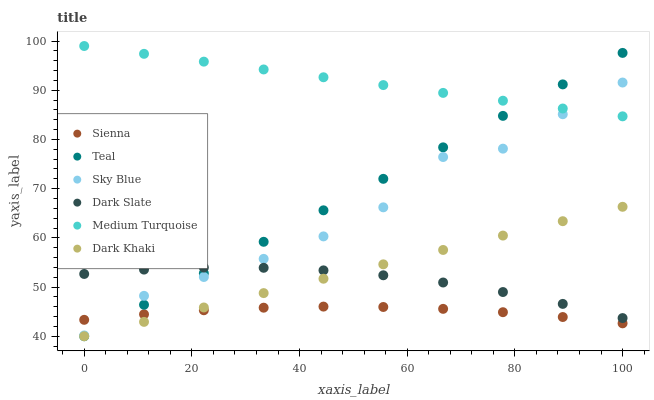Does Sienna have the minimum area under the curve?
Answer yes or no. Yes. Does Medium Turquoise have the maximum area under the curve?
Answer yes or no. Yes. Does Teal have the minimum area under the curve?
Answer yes or no. No. Does Teal have the maximum area under the curve?
Answer yes or no. No. Is Dark Khaki the smoothest?
Answer yes or no. Yes. Is Sky Blue the roughest?
Answer yes or no. Yes. Is Sienna the smoothest?
Answer yes or no. No. Is Sienna the roughest?
Answer yes or no. No. Does Dark Khaki have the lowest value?
Answer yes or no. Yes. Does Sienna have the lowest value?
Answer yes or no. No. Does Medium Turquoise have the highest value?
Answer yes or no. Yes. Does Teal have the highest value?
Answer yes or no. No. Is Dark Khaki less than Sky Blue?
Answer yes or no. Yes. Is Medium Turquoise greater than Dark Slate?
Answer yes or no. Yes. Does Sky Blue intersect Teal?
Answer yes or no. Yes. Is Sky Blue less than Teal?
Answer yes or no. No. Is Sky Blue greater than Teal?
Answer yes or no. No. Does Dark Khaki intersect Sky Blue?
Answer yes or no. No. 